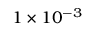Convert formula to latex. <formula><loc_0><loc_0><loc_500><loc_500>1 \times 1 0 ^ { - 3 }</formula> 